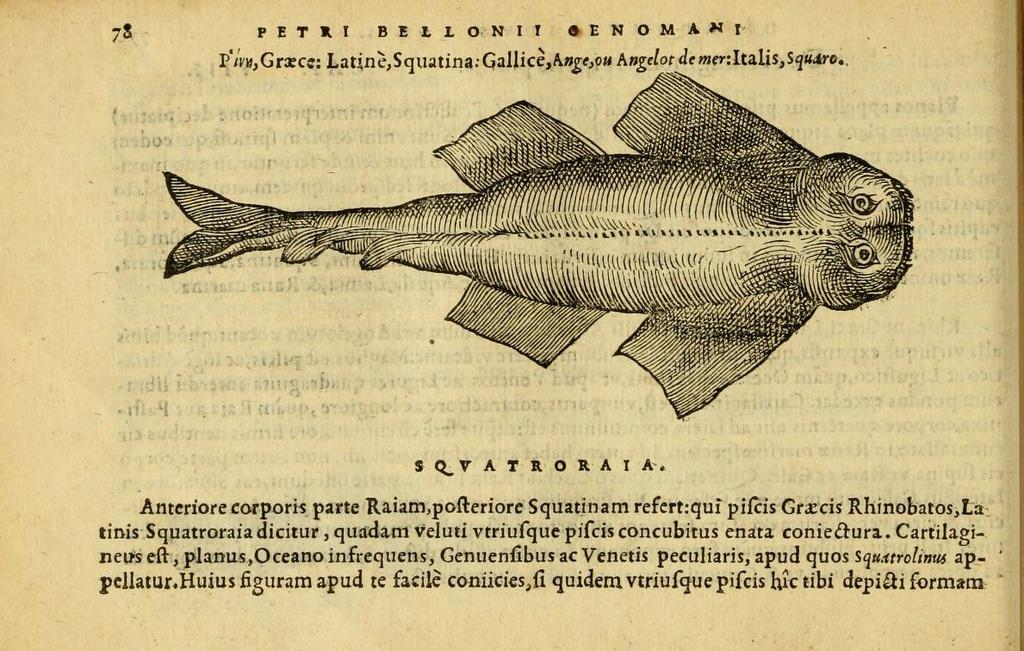What is the main subject of the image? There is a photo in the image. What is depicted in the photo? The photo contains a fish. Are there any words or letters in the photo? Yes, there is text in the photo. What type of popcorn is being served in the image? There is no popcorn present in the image; it features a photo with a fish and text. What spark can be seen coming from the fish in the image? There is no spark present in the image; the fish is depicted in a photo with text. 